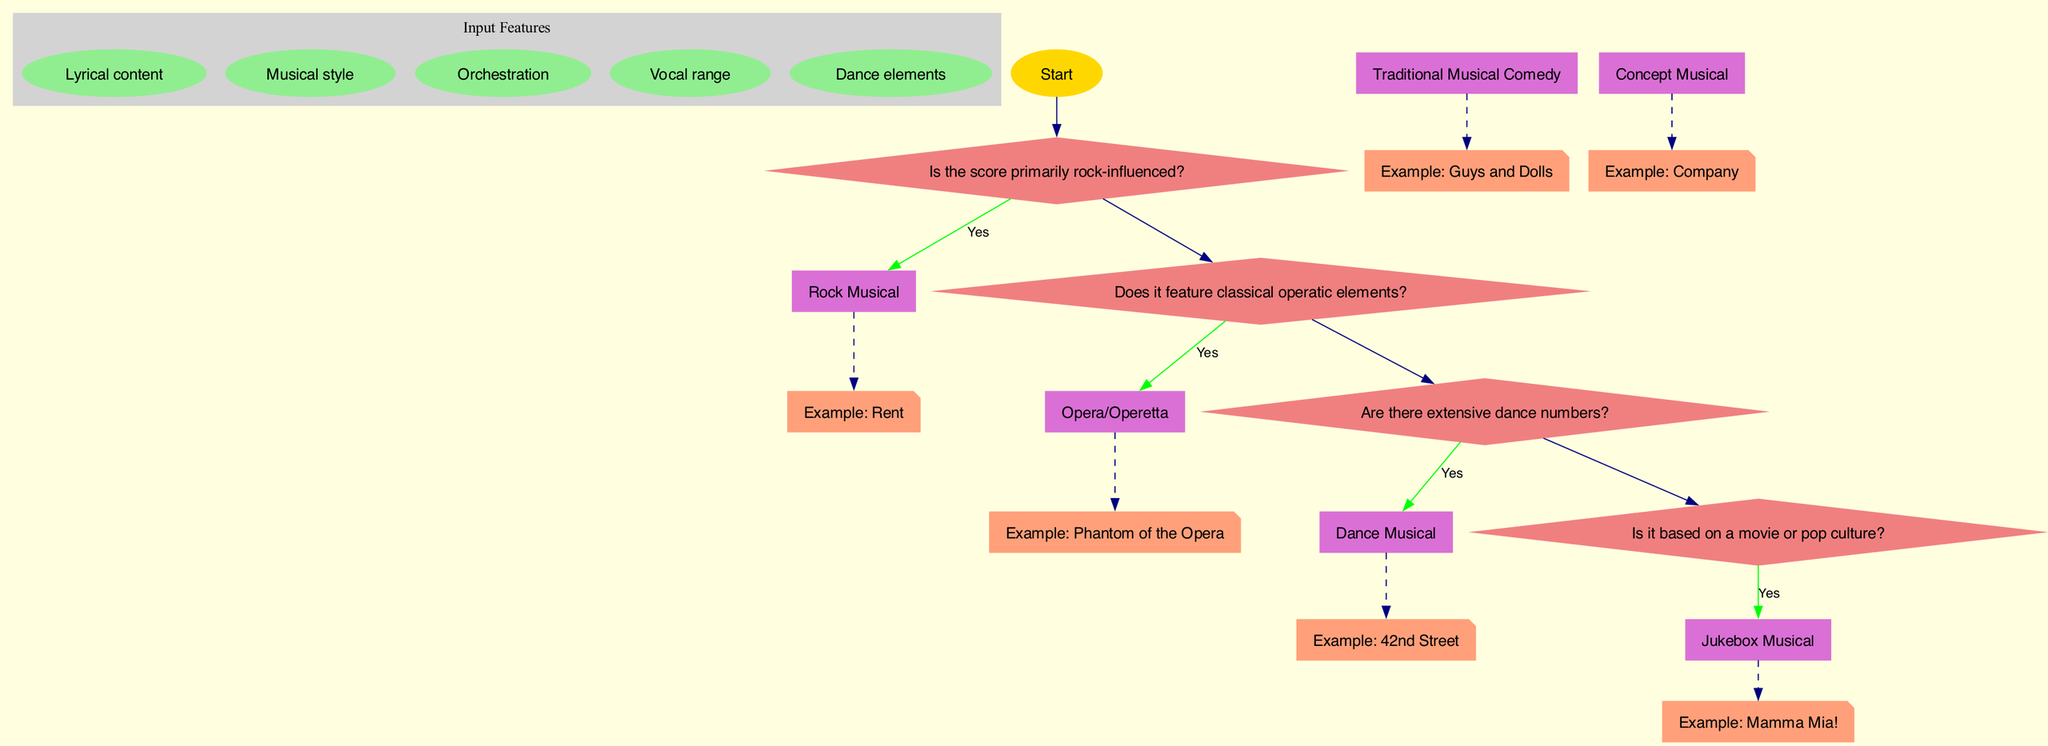What are the input features used in this decision tree? The diagram specifies five input features: Lyrical content, Musical style, Orchestration, Vocal range, and Dance elements. These features are presented in a separate cluster labeled 'Input Features' within the diagram.
Answer: Lyrical content, Musical style, Orchestration, Vocal range, Dance elements How many decision nodes are present in the diagram? The diagram contains four decision nodes, each corresponding to a question that helps classify the Broadway musicals into genres. These nodes are arranged sequentially, leading to different genre classifications.
Answer: 4 What is the first question in the decision tree? The first decision node in the diagram asks, "Is the score primarily rock-influenced?" This question is crucial as it determines the first classification path for the musicals.
Answer: Is the score primarily rock-influenced? If the answer to the first question is "yes," what genre does it classify as? If the answer to the first question is "yes," the decision tree classifies the musical as a "Rock Musical." This result directly connects to the "yes" branch of the first decision node.
Answer: Rock Musical Which genre is classified if the answer to the third question is "no"? The third decision node asks if there are extensive dance numbers. If the answer is "no," the flow continues to the next node, where the question regarding movie or pop culture origins is posed, suggesting that it may still classify into genres beyond Dance Musical.
Answer: Next Node What musical is an example of a Jukebox Musical? The diagram provides a specific example of a Jukebox Musical, which is "Mamma Mia!". This reference is indicated by a dashed edge connecting the genre to the example in the diagram.
Answer: Mamma Mia! What color is used to depict decision nodes in the diagram? The decision nodes in the diagram are represented using the color light coral. This color scheme helps distinguish decision nodes from the input features and genre classifications visually.
Answer: Light coral What type of diagram is this? This diagram is specifically a decision tree model, which is used to classify Broadway musicals into different genres based on their characteristics. The structure allows for a clear representation of the decision-making process involved in the classification.
Answer: Decision tree model 